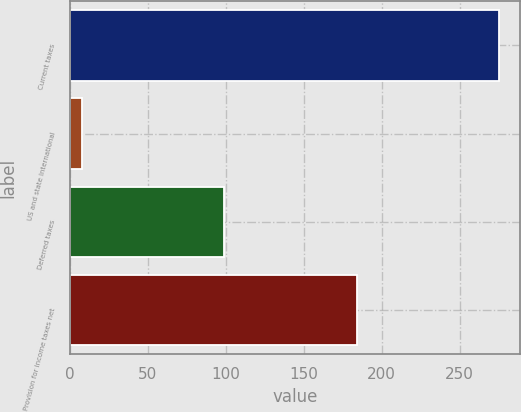Convert chart. <chart><loc_0><loc_0><loc_500><loc_500><bar_chart><fcel>Current taxes<fcel>US and state International<fcel>Deferred taxes<fcel>Provision for income taxes net<nl><fcel>275<fcel>8<fcel>99<fcel>184<nl></chart> 